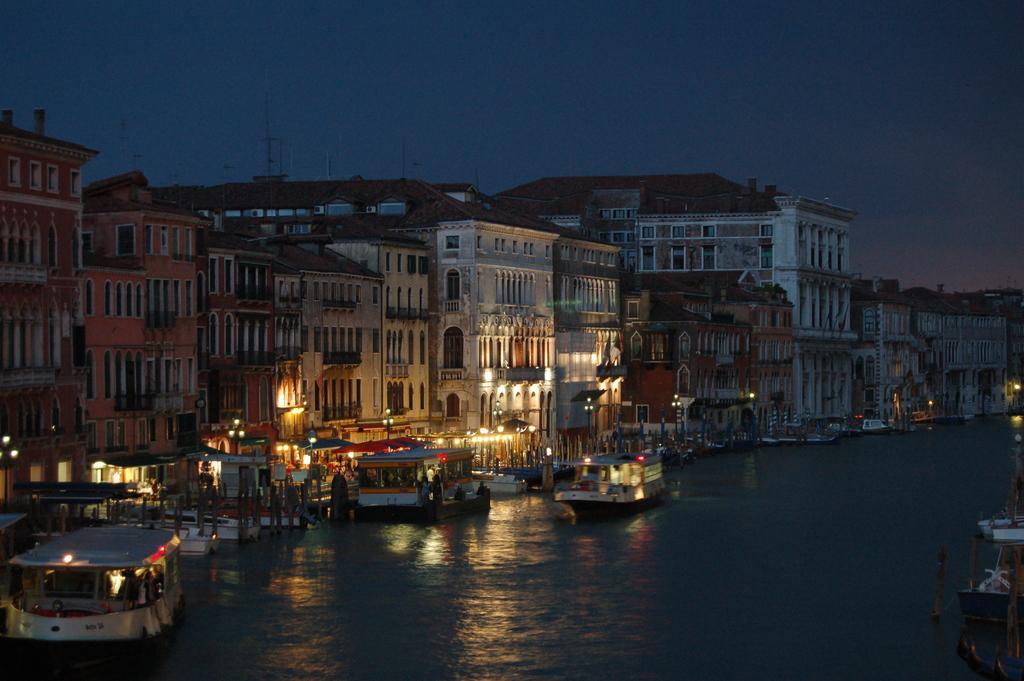Could you give a brief overview of what you see in this image? In this image in the center there are ships sailing on the water. In the background there are buildings and there are lights. 